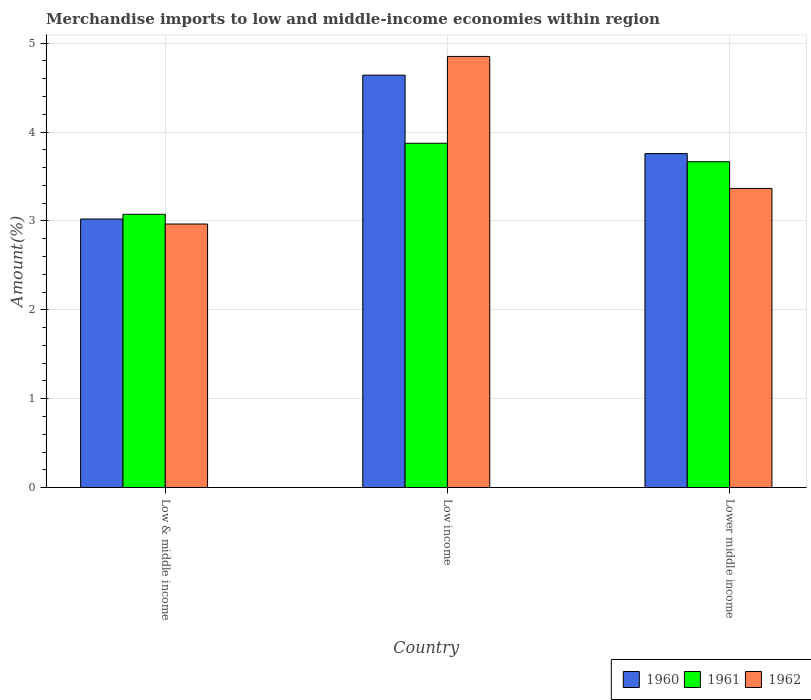How many groups of bars are there?
Provide a short and direct response. 3. Are the number of bars per tick equal to the number of legend labels?
Your answer should be compact. Yes. Are the number of bars on each tick of the X-axis equal?
Give a very brief answer. Yes. What is the percentage of amount earned from merchandise imports in 1960 in Low income?
Provide a succinct answer. 4.64. Across all countries, what is the maximum percentage of amount earned from merchandise imports in 1962?
Keep it short and to the point. 4.85. Across all countries, what is the minimum percentage of amount earned from merchandise imports in 1962?
Your response must be concise. 2.96. What is the total percentage of amount earned from merchandise imports in 1960 in the graph?
Your response must be concise. 11.42. What is the difference between the percentage of amount earned from merchandise imports in 1960 in Low & middle income and that in Low income?
Your answer should be very brief. -1.62. What is the difference between the percentage of amount earned from merchandise imports in 1961 in Low income and the percentage of amount earned from merchandise imports in 1962 in Lower middle income?
Provide a short and direct response. 0.51. What is the average percentage of amount earned from merchandise imports in 1962 per country?
Offer a very short reply. 3.73. What is the difference between the percentage of amount earned from merchandise imports of/in 1961 and percentage of amount earned from merchandise imports of/in 1960 in Lower middle income?
Offer a terse response. -0.09. In how many countries, is the percentage of amount earned from merchandise imports in 1960 greater than 3.8 %?
Give a very brief answer. 1. What is the ratio of the percentage of amount earned from merchandise imports in 1960 in Low & middle income to that in Lower middle income?
Provide a succinct answer. 0.8. What is the difference between the highest and the second highest percentage of amount earned from merchandise imports in 1960?
Your answer should be compact. -0.74. What is the difference between the highest and the lowest percentage of amount earned from merchandise imports in 1961?
Offer a terse response. 0.8. In how many countries, is the percentage of amount earned from merchandise imports in 1961 greater than the average percentage of amount earned from merchandise imports in 1961 taken over all countries?
Give a very brief answer. 2. What does the 1st bar from the right in Low & middle income represents?
Provide a short and direct response. 1962. How many bars are there?
Your answer should be very brief. 9. How many countries are there in the graph?
Give a very brief answer. 3. What is the difference between two consecutive major ticks on the Y-axis?
Provide a succinct answer. 1. Does the graph contain any zero values?
Provide a succinct answer. No. Does the graph contain grids?
Keep it short and to the point. Yes. Where does the legend appear in the graph?
Offer a terse response. Bottom right. How are the legend labels stacked?
Offer a terse response. Horizontal. What is the title of the graph?
Give a very brief answer. Merchandise imports to low and middle-income economies within region. What is the label or title of the X-axis?
Provide a short and direct response. Country. What is the label or title of the Y-axis?
Make the answer very short. Amount(%). What is the Amount(%) of 1960 in Low & middle income?
Make the answer very short. 3.02. What is the Amount(%) of 1961 in Low & middle income?
Offer a terse response. 3.07. What is the Amount(%) of 1962 in Low & middle income?
Offer a terse response. 2.96. What is the Amount(%) of 1960 in Low income?
Your response must be concise. 4.64. What is the Amount(%) in 1961 in Low income?
Provide a short and direct response. 3.87. What is the Amount(%) of 1962 in Low income?
Give a very brief answer. 4.85. What is the Amount(%) in 1960 in Lower middle income?
Your response must be concise. 3.76. What is the Amount(%) of 1961 in Lower middle income?
Your response must be concise. 3.67. What is the Amount(%) of 1962 in Lower middle income?
Keep it short and to the point. 3.37. Across all countries, what is the maximum Amount(%) of 1960?
Offer a terse response. 4.64. Across all countries, what is the maximum Amount(%) of 1961?
Your answer should be very brief. 3.87. Across all countries, what is the maximum Amount(%) of 1962?
Your response must be concise. 4.85. Across all countries, what is the minimum Amount(%) of 1960?
Make the answer very short. 3.02. Across all countries, what is the minimum Amount(%) of 1961?
Provide a succinct answer. 3.07. Across all countries, what is the minimum Amount(%) in 1962?
Your answer should be very brief. 2.96. What is the total Amount(%) of 1960 in the graph?
Keep it short and to the point. 11.42. What is the total Amount(%) in 1961 in the graph?
Offer a terse response. 10.61. What is the total Amount(%) in 1962 in the graph?
Make the answer very short. 11.18. What is the difference between the Amount(%) in 1960 in Low & middle income and that in Low income?
Give a very brief answer. -1.62. What is the difference between the Amount(%) in 1961 in Low & middle income and that in Low income?
Give a very brief answer. -0.8. What is the difference between the Amount(%) of 1962 in Low & middle income and that in Low income?
Your response must be concise. -1.89. What is the difference between the Amount(%) in 1960 in Low & middle income and that in Lower middle income?
Your response must be concise. -0.74. What is the difference between the Amount(%) in 1961 in Low & middle income and that in Lower middle income?
Your answer should be compact. -0.59. What is the difference between the Amount(%) in 1962 in Low & middle income and that in Lower middle income?
Offer a terse response. -0.4. What is the difference between the Amount(%) in 1960 in Low income and that in Lower middle income?
Ensure brevity in your answer.  0.88. What is the difference between the Amount(%) in 1961 in Low income and that in Lower middle income?
Give a very brief answer. 0.21. What is the difference between the Amount(%) in 1962 in Low income and that in Lower middle income?
Offer a terse response. 1.48. What is the difference between the Amount(%) in 1960 in Low & middle income and the Amount(%) in 1961 in Low income?
Provide a succinct answer. -0.85. What is the difference between the Amount(%) in 1960 in Low & middle income and the Amount(%) in 1962 in Low income?
Provide a short and direct response. -1.83. What is the difference between the Amount(%) of 1961 in Low & middle income and the Amount(%) of 1962 in Low income?
Provide a short and direct response. -1.78. What is the difference between the Amount(%) of 1960 in Low & middle income and the Amount(%) of 1961 in Lower middle income?
Your answer should be very brief. -0.64. What is the difference between the Amount(%) of 1960 in Low & middle income and the Amount(%) of 1962 in Lower middle income?
Your answer should be compact. -0.34. What is the difference between the Amount(%) of 1961 in Low & middle income and the Amount(%) of 1962 in Lower middle income?
Give a very brief answer. -0.29. What is the difference between the Amount(%) of 1960 in Low income and the Amount(%) of 1961 in Lower middle income?
Provide a succinct answer. 0.97. What is the difference between the Amount(%) of 1960 in Low income and the Amount(%) of 1962 in Lower middle income?
Offer a terse response. 1.27. What is the difference between the Amount(%) of 1961 in Low income and the Amount(%) of 1962 in Lower middle income?
Provide a short and direct response. 0.51. What is the average Amount(%) of 1960 per country?
Offer a terse response. 3.81. What is the average Amount(%) in 1961 per country?
Ensure brevity in your answer.  3.54. What is the average Amount(%) of 1962 per country?
Your answer should be very brief. 3.73. What is the difference between the Amount(%) in 1960 and Amount(%) in 1961 in Low & middle income?
Offer a very short reply. -0.05. What is the difference between the Amount(%) of 1960 and Amount(%) of 1962 in Low & middle income?
Keep it short and to the point. 0.06. What is the difference between the Amount(%) of 1961 and Amount(%) of 1962 in Low & middle income?
Make the answer very short. 0.11. What is the difference between the Amount(%) in 1960 and Amount(%) in 1961 in Low income?
Offer a very short reply. 0.77. What is the difference between the Amount(%) of 1960 and Amount(%) of 1962 in Low income?
Give a very brief answer. -0.21. What is the difference between the Amount(%) in 1961 and Amount(%) in 1962 in Low income?
Keep it short and to the point. -0.98. What is the difference between the Amount(%) in 1960 and Amount(%) in 1961 in Lower middle income?
Keep it short and to the point. 0.09. What is the difference between the Amount(%) in 1960 and Amount(%) in 1962 in Lower middle income?
Make the answer very short. 0.39. What is the difference between the Amount(%) in 1961 and Amount(%) in 1962 in Lower middle income?
Offer a terse response. 0.3. What is the ratio of the Amount(%) in 1960 in Low & middle income to that in Low income?
Ensure brevity in your answer.  0.65. What is the ratio of the Amount(%) of 1961 in Low & middle income to that in Low income?
Make the answer very short. 0.79. What is the ratio of the Amount(%) of 1962 in Low & middle income to that in Low income?
Make the answer very short. 0.61. What is the ratio of the Amount(%) of 1960 in Low & middle income to that in Lower middle income?
Ensure brevity in your answer.  0.8. What is the ratio of the Amount(%) in 1961 in Low & middle income to that in Lower middle income?
Make the answer very short. 0.84. What is the ratio of the Amount(%) in 1962 in Low & middle income to that in Lower middle income?
Your answer should be compact. 0.88. What is the ratio of the Amount(%) in 1960 in Low income to that in Lower middle income?
Provide a succinct answer. 1.23. What is the ratio of the Amount(%) in 1961 in Low income to that in Lower middle income?
Provide a short and direct response. 1.06. What is the ratio of the Amount(%) of 1962 in Low income to that in Lower middle income?
Your response must be concise. 1.44. What is the difference between the highest and the second highest Amount(%) of 1960?
Provide a short and direct response. 0.88. What is the difference between the highest and the second highest Amount(%) of 1961?
Your response must be concise. 0.21. What is the difference between the highest and the second highest Amount(%) of 1962?
Give a very brief answer. 1.48. What is the difference between the highest and the lowest Amount(%) in 1960?
Offer a very short reply. 1.62. What is the difference between the highest and the lowest Amount(%) in 1961?
Make the answer very short. 0.8. What is the difference between the highest and the lowest Amount(%) of 1962?
Offer a terse response. 1.89. 